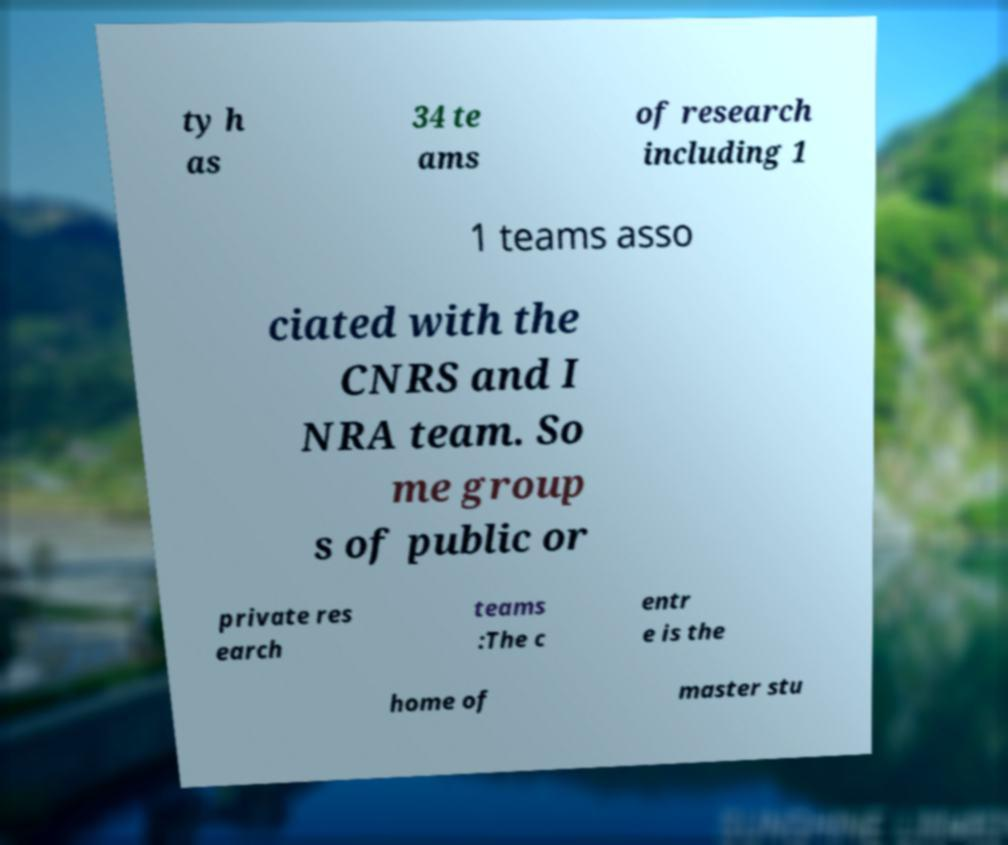Can you accurately transcribe the text from the provided image for me? ty h as 34 te ams of research including 1 1 teams asso ciated with the CNRS and I NRA team. So me group s of public or private res earch teams :The c entr e is the home of master stu 